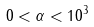Convert formula to latex. <formula><loc_0><loc_0><loc_500><loc_500>0 < \alpha < 1 0 ^ { 3 } \,</formula> 